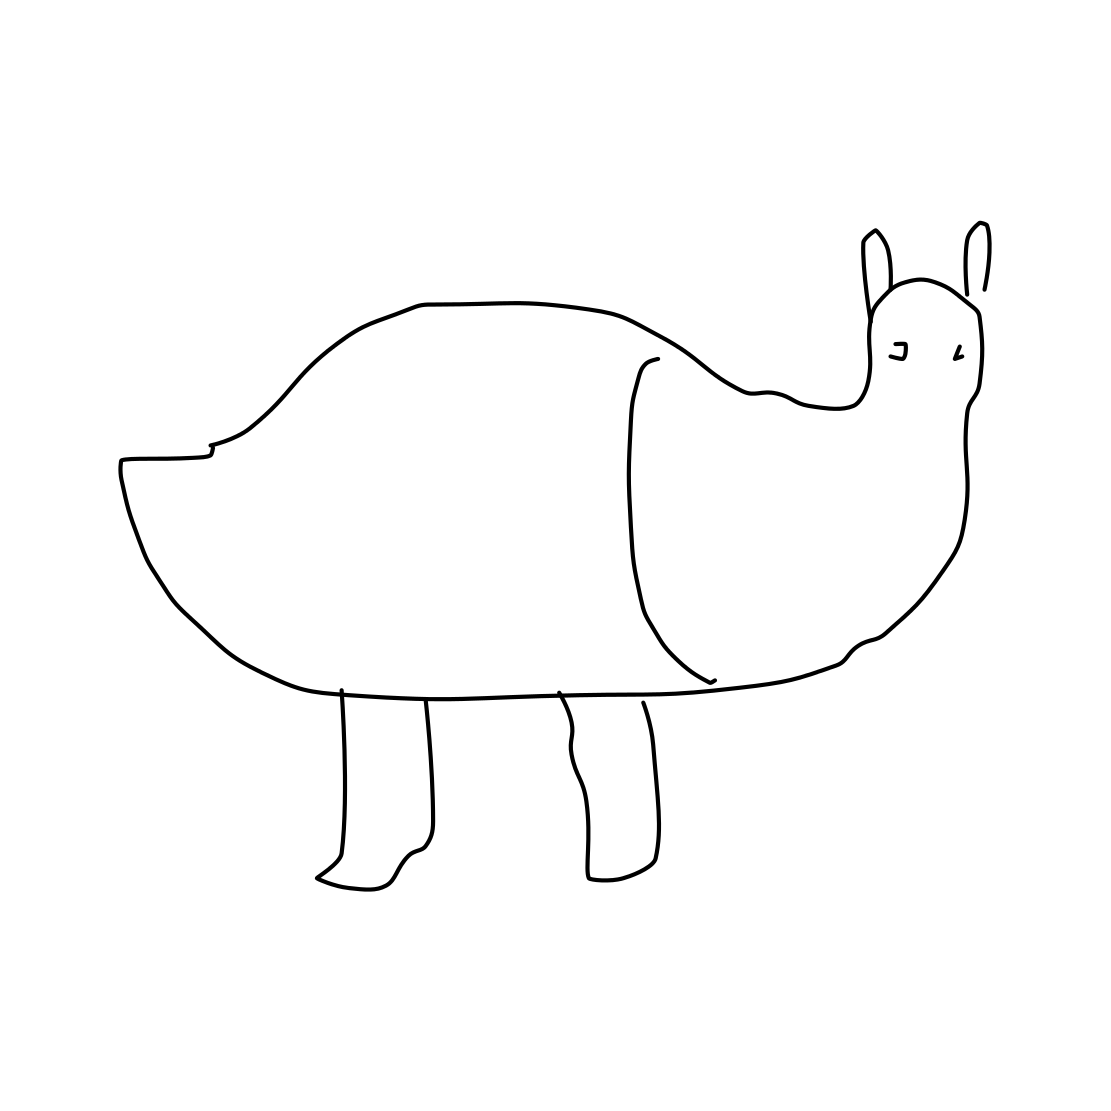Is this a kangaroo in the image? Actually, the image does not depict a kangaroo. While the simplistic drawing has some attributes that might remind someone of a kangaroo, such as the ears and possibly the shape of the back, it lacks other definitive characteristics, such as the powerful hind legs and long tail associated with kangaroos. It seems to be a stylized or abstract representation of an animal, but it does not provide enough detail to confirm it as a specific species. 